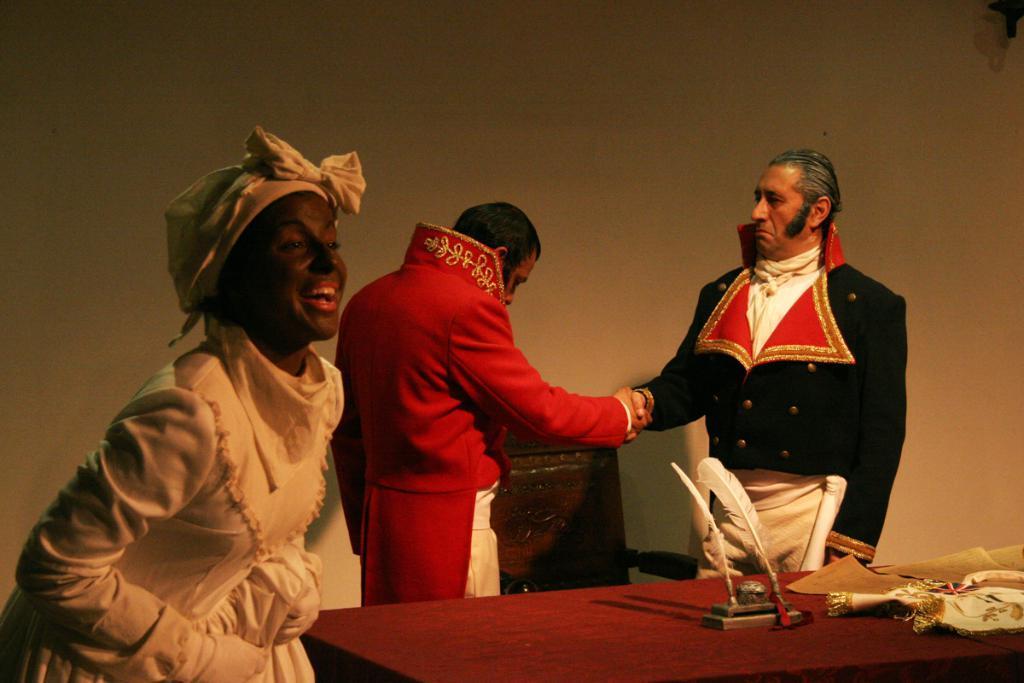In one or two sentences, can you explain what this image depicts? In this image there are people standing and there is a table, on that table there are few objects, in the background there is a wall. 